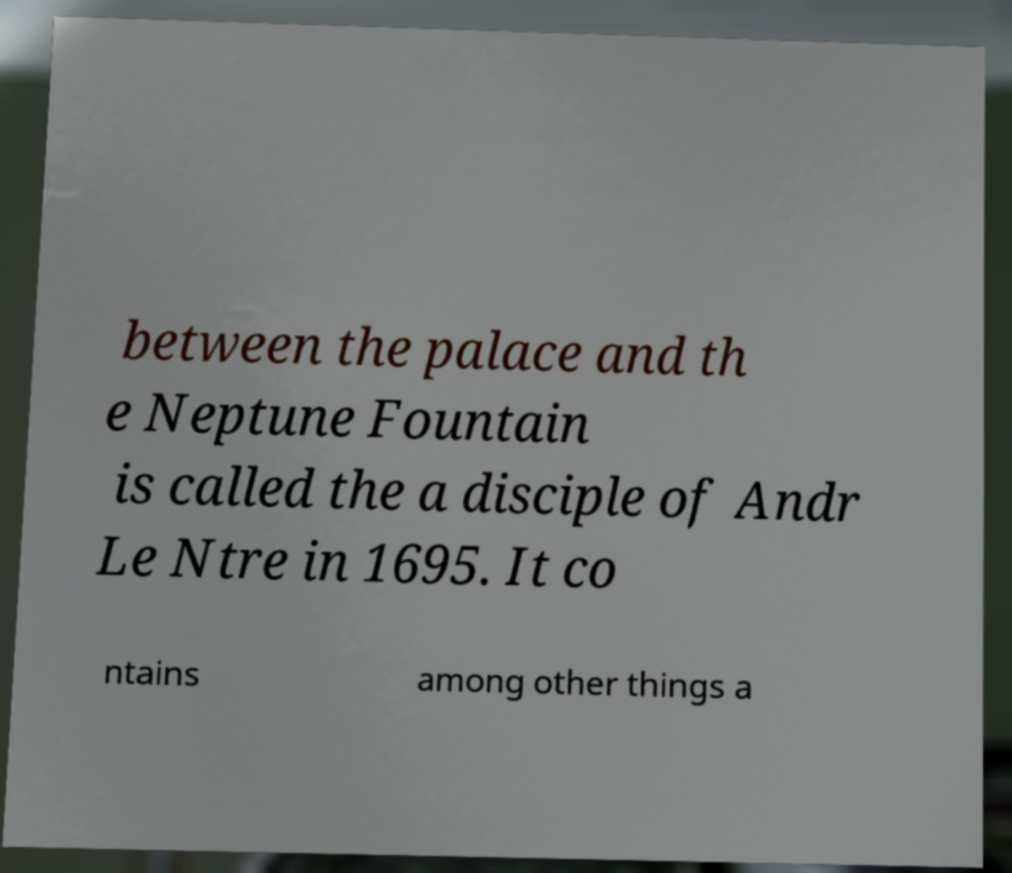Please read and relay the text visible in this image. What does it say? between the palace and th e Neptune Fountain is called the a disciple of Andr Le Ntre in 1695. It co ntains among other things a 